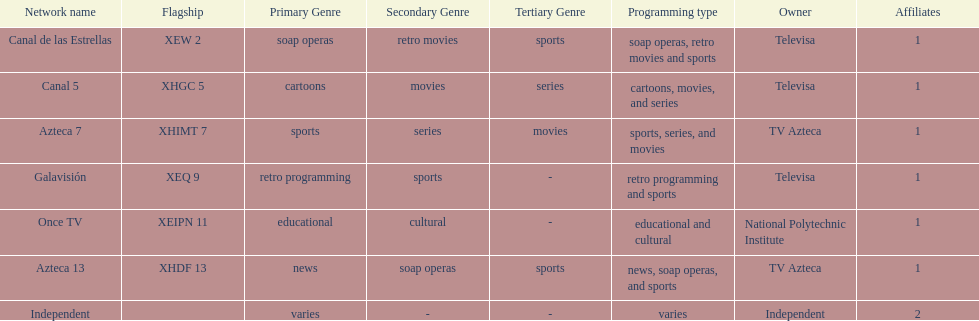I'm looking to parse the entire table for insights. Could you assist me with that? {'header': ['Network name', 'Flagship', 'Primary Genre', 'Secondary Genre', 'Tertiary Genre', 'Programming type', 'Owner', 'Affiliates'], 'rows': [['Canal de las Estrellas', 'XEW 2', 'soap operas', 'retro movies', 'sports', 'soap operas, retro movies and sports', 'Televisa', '1'], ['Canal 5', 'XHGC 5', 'cartoons', 'movies', 'series', 'cartoons, movies, and series', 'Televisa', '1'], ['Azteca 7', 'XHIMT 7', 'sports', 'series', 'movies', 'sports, series, and movies', 'TV Azteca', '1'], ['Galavisión', 'XEQ 9', 'retro programming', 'sports', '-', 'retro programming and sports', 'Televisa', '1'], ['Once TV', 'XEIPN 11', 'educational', 'cultural', '-', 'educational and cultural', 'National Polytechnic Institute', '1'], ['Azteca 13', 'XHDF 13', 'news', 'soap operas', 'sports', 'news, soap operas, and sports', 'TV Azteca', '1'], ['Independent', '', 'varies', '-', '-', 'varies', 'Independent', '2']]} What is the count of tv networks that tv azteca possesses? 2. 